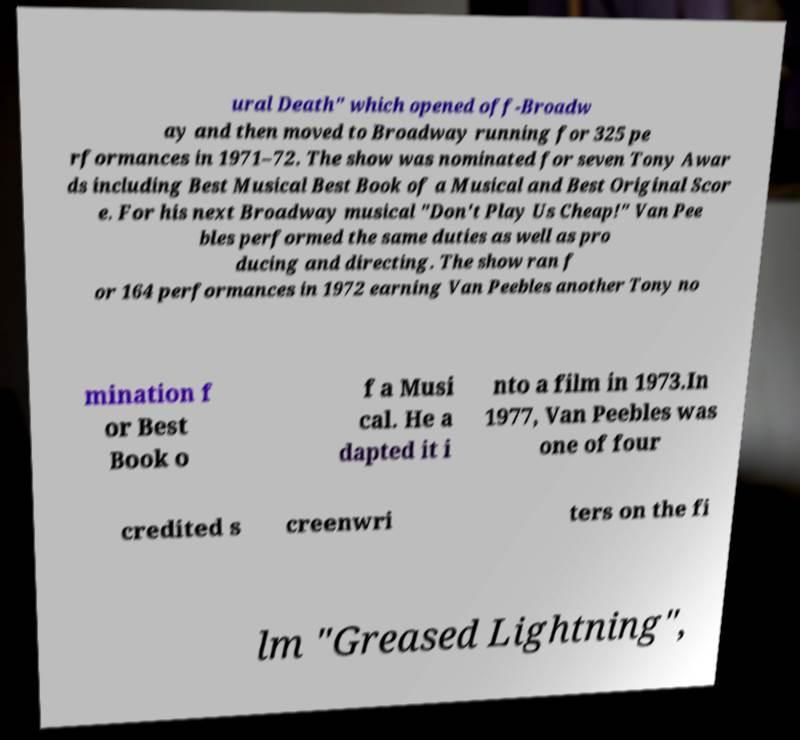Please read and relay the text visible in this image. What does it say? ural Death" which opened off-Broadw ay and then moved to Broadway running for 325 pe rformances in 1971–72. The show was nominated for seven Tony Awar ds including Best Musical Best Book of a Musical and Best Original Scor e. For his next Broadway musical "Don't Play Us Cheap!" Van Pee bles performed the same duties as well as pro ducing and directing. The show ran f or 164 performances in 1972 earning Van Peebles another Tony no mination f or Best Book o f a Musi cal. He a dapted it i nto a film in 1973.In 1977, Van Peebles was one of four credited s creenwri ters on the fi lm "Greased Lightning", 